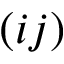<formula> <loc_0><loc_0><loc_500><loc_500>( i j )</formula> 